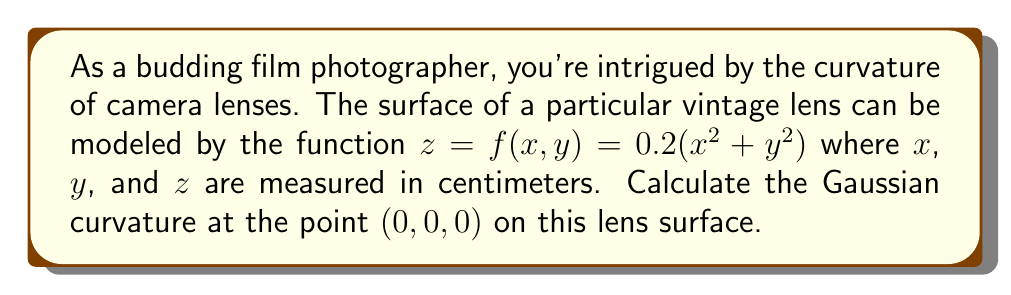Give your solution to this math problem. To find the Gaussian curvature of the lens surface, we need to follow these steps:

1) The Gaussian curvature K is given by:

   $$K = \frac{f_{xx}f_{yy} - f_{xy}^2}{(1 + f_x^2 + f_y^2)^2}$$

   where subscripts denote partial derivatives.

2) Let's calculate the required partial derivatives:

   $f_x = 0.4x$
   $f_y = 0.4y$
   $f_{xx} = 0.4$
   $f_{yy} = 0.4$
   $f_{xy} = 0$

3) At the point (0, 0, 0):

   $f_x = f_y = 0$
   $f_{xx} = f_{yy} = 0.4$
   $f_{xy} = 0$

4) Now, let's substitute these values into the Gaussian curvature formula:

   $$K = \frac{(0.4)(0.4) - 0^2}{(1 + 0^2 + 0^2)^2} = \frac{0.16}{1} = 0.16$$

5) Therefore, the Gaussian curvature at (0, 0, 0) is 0.16 cm^(-2).

This positive Gaussian curvature indicates that the lens surface is convex at this point, which is typical for camera lenses used to focus light onto the film.
Answer: The Gaussian curvature at the point (0, 0, 0) on the lens surface is 0.16 cm^(-2). 